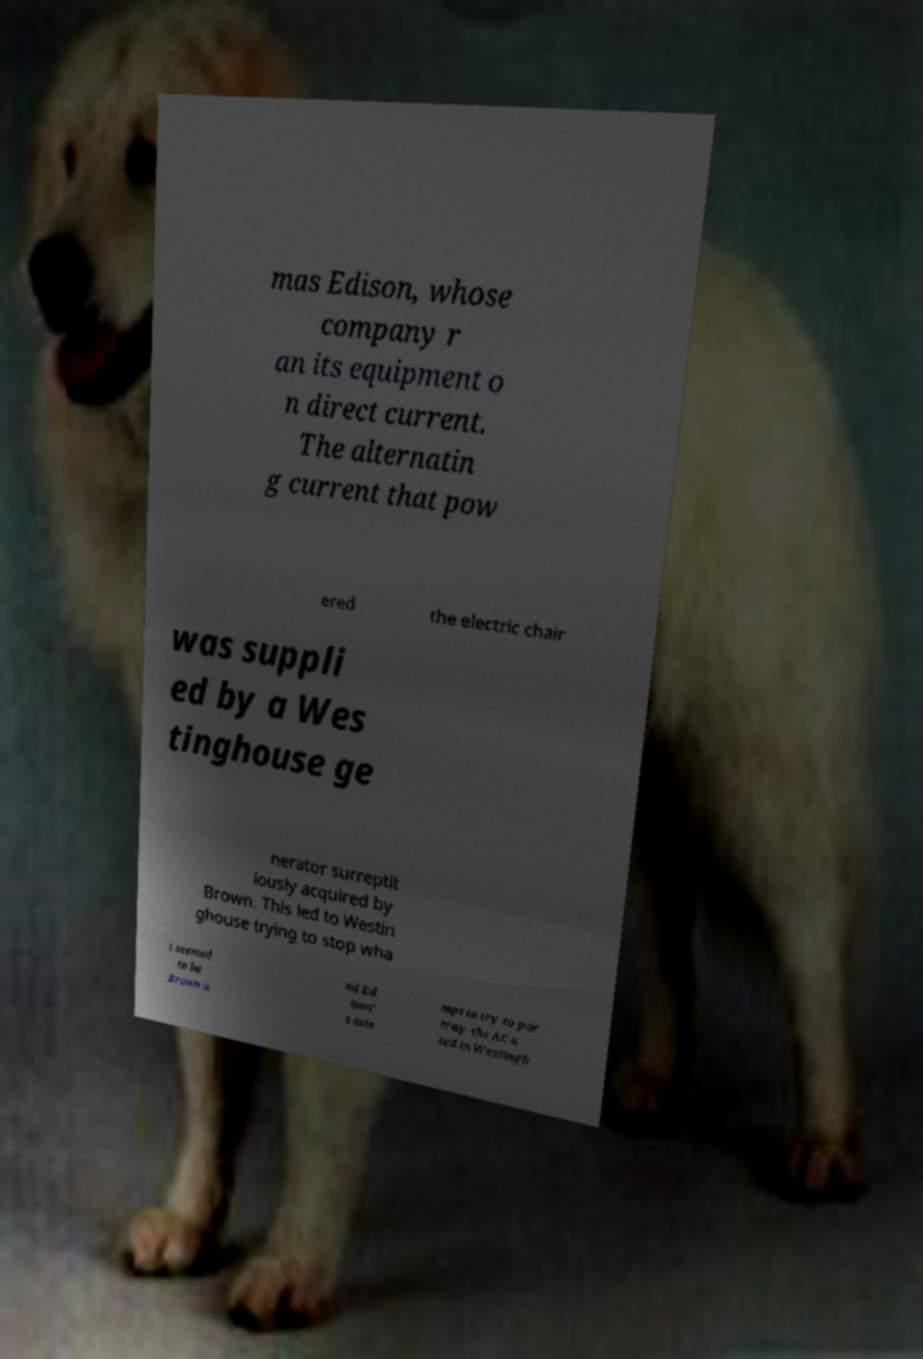Please read and relay the text visible in this image. What does it say? mas Edison, whose company r an its equipment o n direct current. The alternatin g current that pow ered the electric chair was suppli ed by a Wes tinghouse ge nerator surreptit iously acquired by Brown. This led to Westin ghouse trying to stop wha t seemed to be Brown a nd Ed ison' s atte mpt to try to por tray the AC u sed in Westingh 